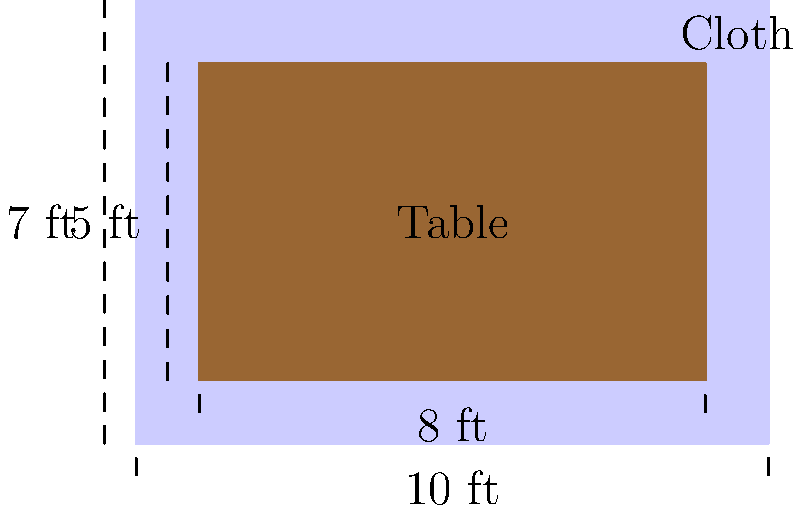For the altar in our church, we have a rectangular table that measures 8 feet long and 5 feet wide. We want to create a new altar cloth that hangs down 1 foot on each side of the table. What should be the dimensions of the rectangular altar cloth to properly cover the table? To determine the dimensions of the altar cloth, we need to consider both the table size and the desired overhang. Let's approach this step-by-step:

1. Table dimensions:
   - Length = 8 feet
   - Width = 5 feet

2. Desired overhang:
   - 1 foot on each side

3. Calculate the length of the altar cloth:
   - Cloth length = Table length + (2 × Overhang)
   - Cloth length = 8 + (2 × 1) = 8 + 2 = 10 feet

4. Calculate the width of the altar cloth:
   - Cloth width = Table width + (2 × Overhang)
   - Cloth width = 5 + (2 × 1) = 5 + 2 = 7 feet

Therefore, the dimensions of the rectangular altar cloth should be 10 feet long and 7 feet wide to properly cover the table with a 1-foot overhang on each side.
Answer: 10 feet × 7 feet 